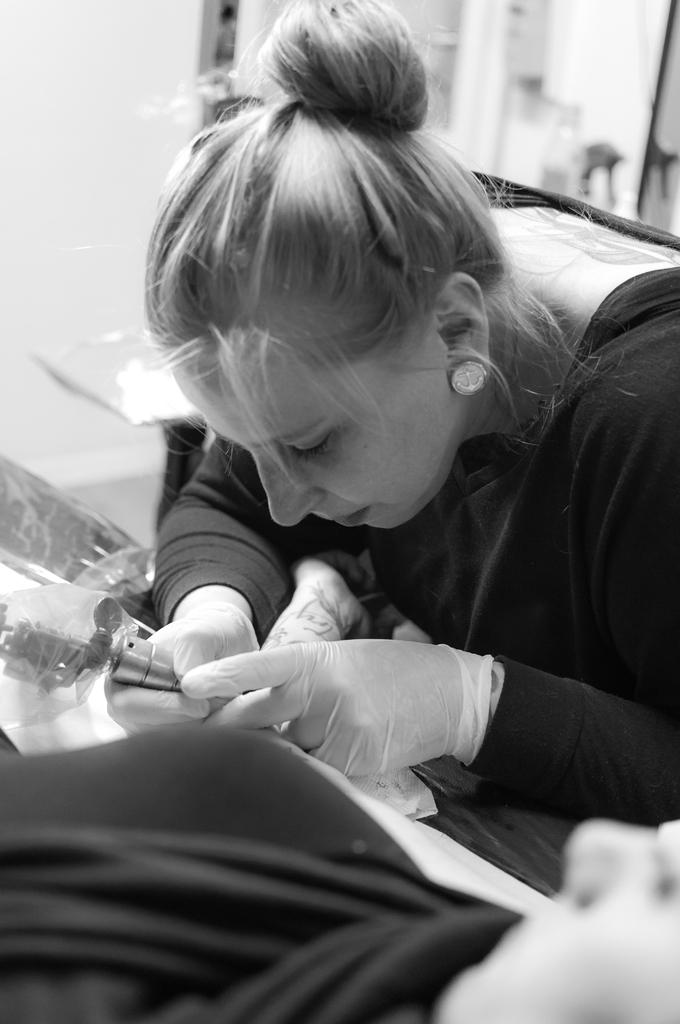Who is the main subject in the image? There is a woman in the image. What is the woman wearing? The woman is wearing a black dress. What activity is the woman engaged in? The woman appears to be making a tattoo. What type of stone is the woman using to make the popcorn in the image? There is no stone or popcorn present in the image. The woman is making a tattoo, not popcorn. 